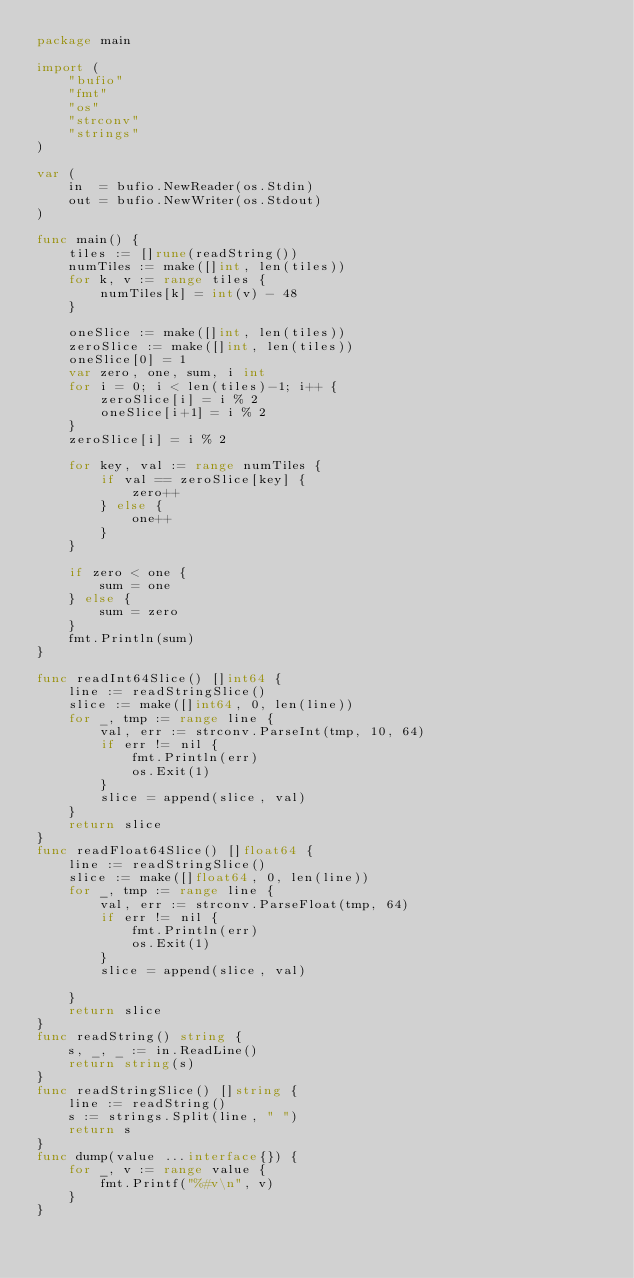Convert code to text. <code><loc_0><loc_0><loc_500><loc_500><_Go_>package main

import (
	"bufio"
	"fmt"
	"os"
	"strconv"
	"strings"
)

var (
	in  = bufio.NewReader(os.Stdin)
	out = bufio.NewWriter(os.Stdout)
)

func main() {
	tiles := []rune(readString())
	numTiles := make([]int, len(tiles))
	for k, v := range tiles {
		numTiles[k] = int(v) - 48
	}

	oneSlice := make([]int, len(tiles))
	zeroSlice := make([]int, len(tiles))
	oneSlice[0] = 1
	var zero, one, sum, i int
	for i = 0; i < len(tiles)-1; i++ {
		zeroSlice[i] = i % 2
		oneSlice[i+1] = i % 2
	}
	zeroSlice[i] = i % 2

	for key, val := range numTiles {
		if val == zeroSlice[key] {
			zero++
		} else {
			one++
		}
	}

	if zero < one {
		sum = one
	} else {
		sum = zero
	}
	fmt.Println(sum)
}

func readInt64Slice() []int64 {
	line := readStringSlice()
	slice := make([]int64, 0, len(line))
	for _, tmp := range line {
		val, err := strconv.ParseInt(tmp, 10, 64)
		if err != nil {
			fmt.Println(err)
			os.Exit(1)
		}
		slice = append(slice, val)
	}
	return slice
}
func readFloat64Slice() []float64 {
	line := readStringSlice()
	slice := make([]float64, 0, len(line))
	for _, tmp := range line {
		val, err := strconv.ParseFloat(tmp, 64)
		if err != nil {
			fmt.Println(err)
			os.Exit(1)
		}
		slice = append(slice, val)

	}
	return slice
}
func readString() string {
	s, _, _ := in.ReadLine()
	return string(s)
}
func readStringSlice() []string {
	line := readString()
	s := strings.Split(line, " ")
	return s
}
func dump(value ...interface{}) {
	for _, v := range value {
		fmt.Printf("%#v\n", v)
	}
}
</code> 